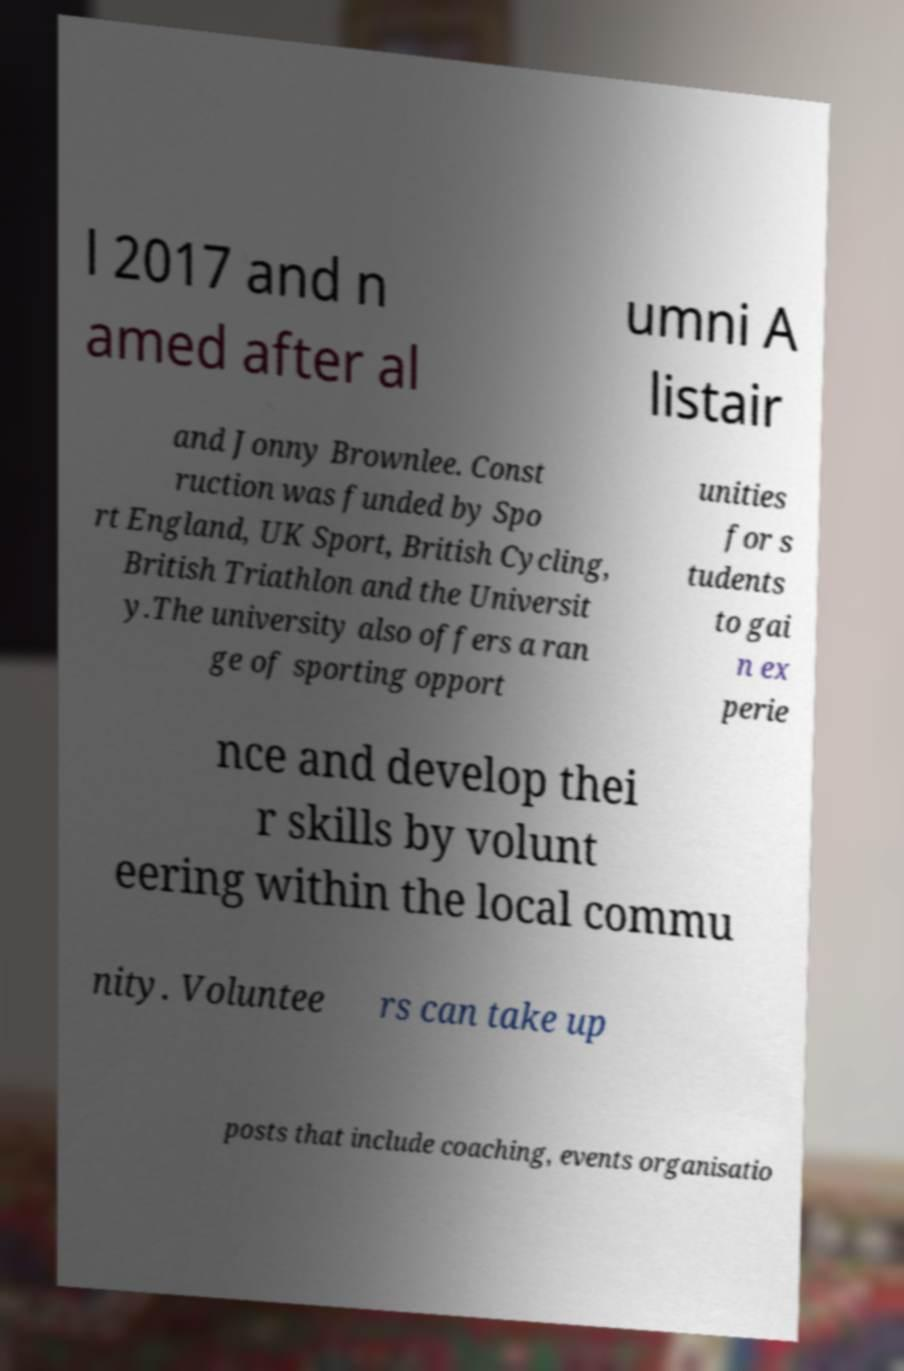Could you extract and type out the text from this image? l 2017 and n amed after al umni A listair and Jonny Brownlee. Const ruction was funded by Spo rt England, UK Sport, British Cycling, British Triathlon and the Universit y.The university also offers a ran ge of sporting opport unities for s tudents to gai n ex perie nce and develop thei r skills by volunt eering within the local commu nity. Voluntee rs can take up posts that include coaching, events organisatio 